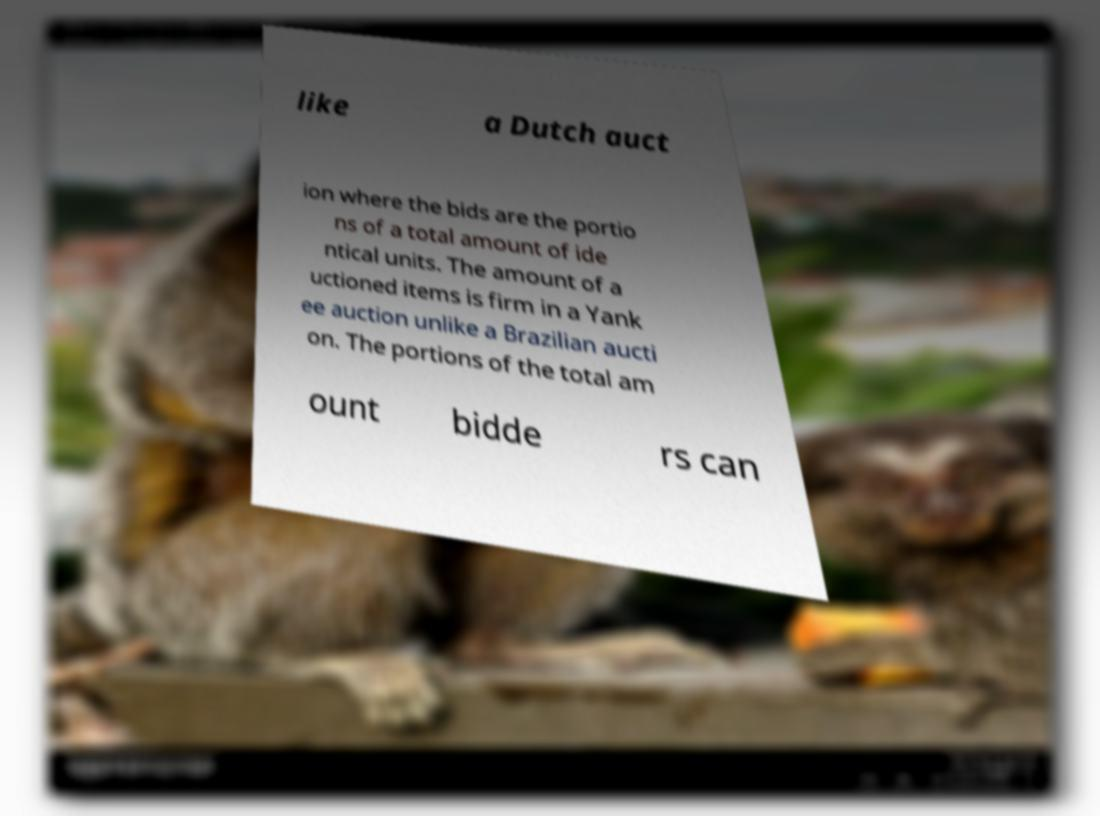Please identify and transcribe the text found in this image. like a Dutch auct ion where the bids are the portio ns of a total amount of ide ntical units. The amount of a uctioned items is firm in a Yank ee auction unlike a Brazilian aucti on. The portions of the total am ount bidde rs can 